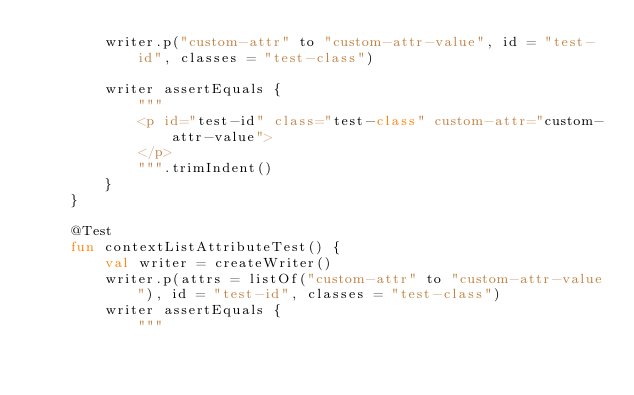<code> <loc_0><loc_0><loc_500><loc_500><_Kotlin_>        writer.p("custom-attr" to "custom-attr-value", id = "test-id", classes = "test-class")

        writer assertEquals {
            """
            <p id="test-id" class="test-class" custom-attr="custom-attr-value">
            </p>
            """.trimIndent()
        }
    }

    @Test
    fun contextListAttributeTest() {
        val writer = createWriter()
        writer.p(attrs = listOf("custom-attr" to "custom-attr-value"), id = "test-id", classes = "test-class")
        writer assertEquals {
            """</code> 